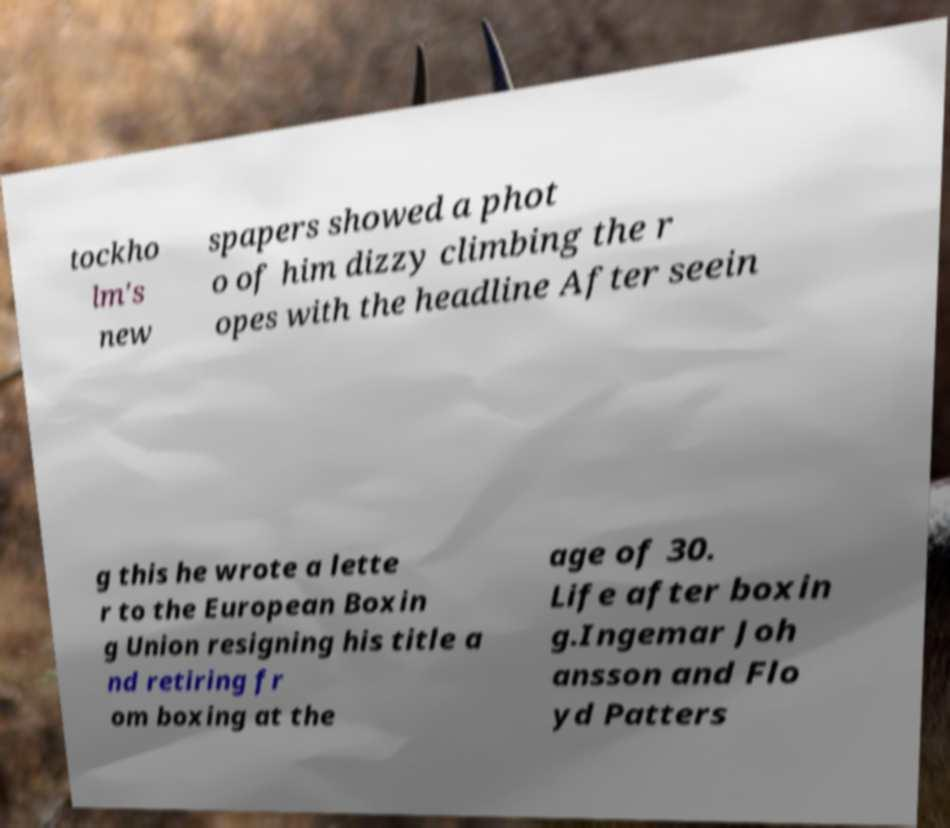Could you extract and type out the text from this image? tockho lm's new spapers showed a phot o of him dizzy climbing the r opes with the headline After seein g this he wrote a lette r to the European Boxin g Union resigning his title a nd retiring fr om boxing at the age of 30. Life after boxin g.Ingemar Joh ansson and Flo yd Patters 